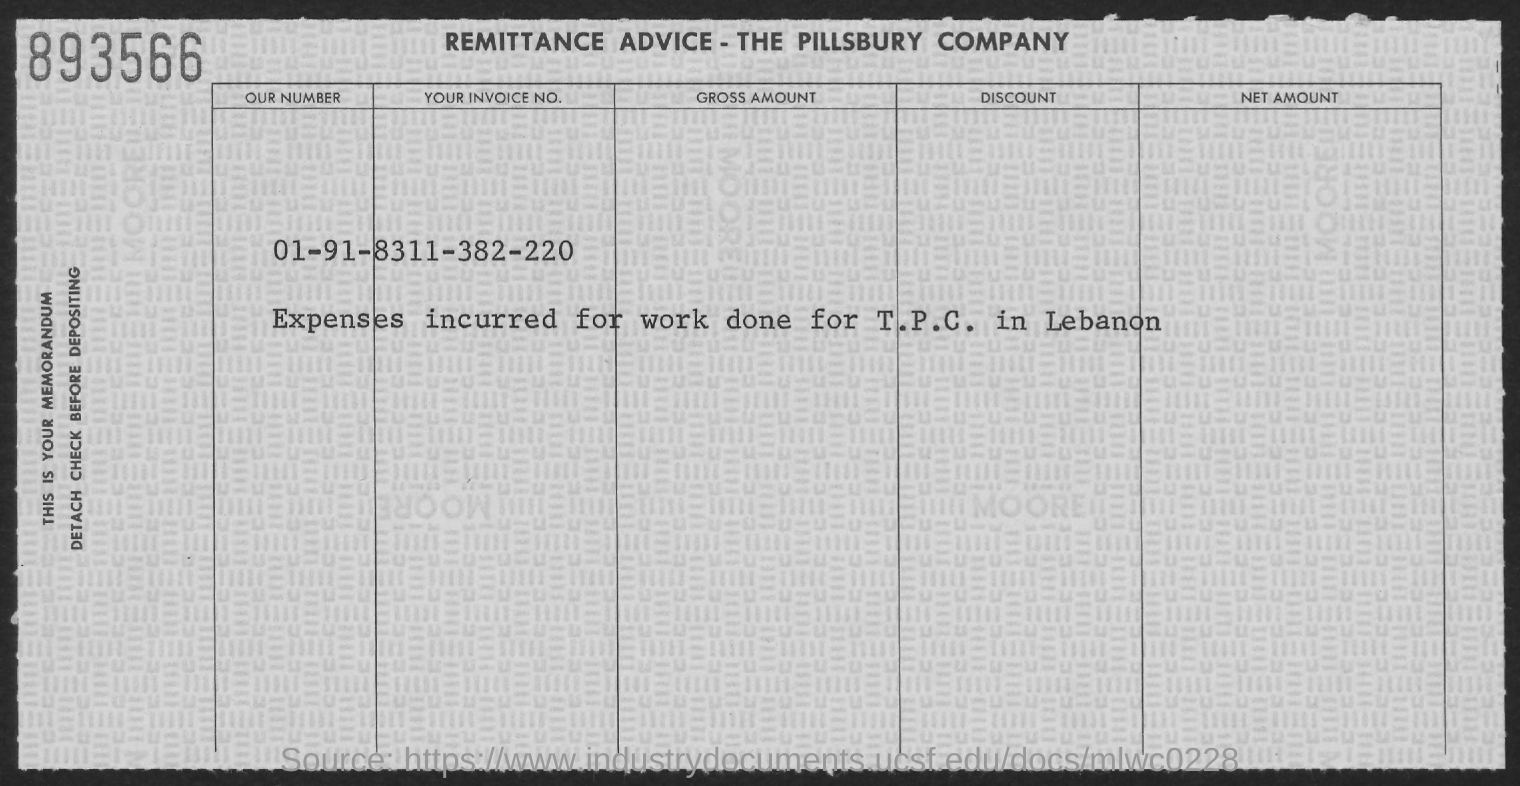Outline some significant characteristics in this image. I incurred expenses for work I performed for t.p.c. in Lebanon. What is the Tour Invoice No.? 8311-382-220..." is a question asking for information about a specific invoice number. 